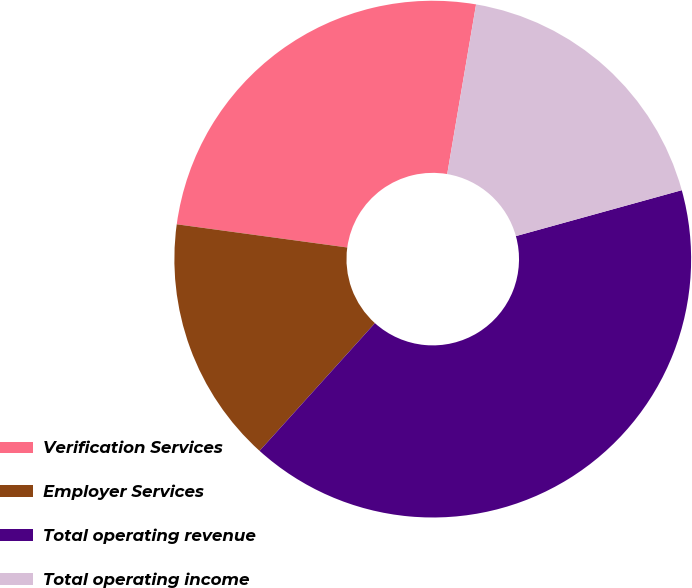Convert chart to OTSL. <chart><loc_0><loc_0><loc_500><loc_500><pie_chart><fcel>Verification Services<fcel>Employer Services<fcel>Total operating revenue<fcel>Total operating income<nl><fcel>25.53%<fcel>15.46%<fcel>40.99%<fcel>18.02%<nl></chart> 